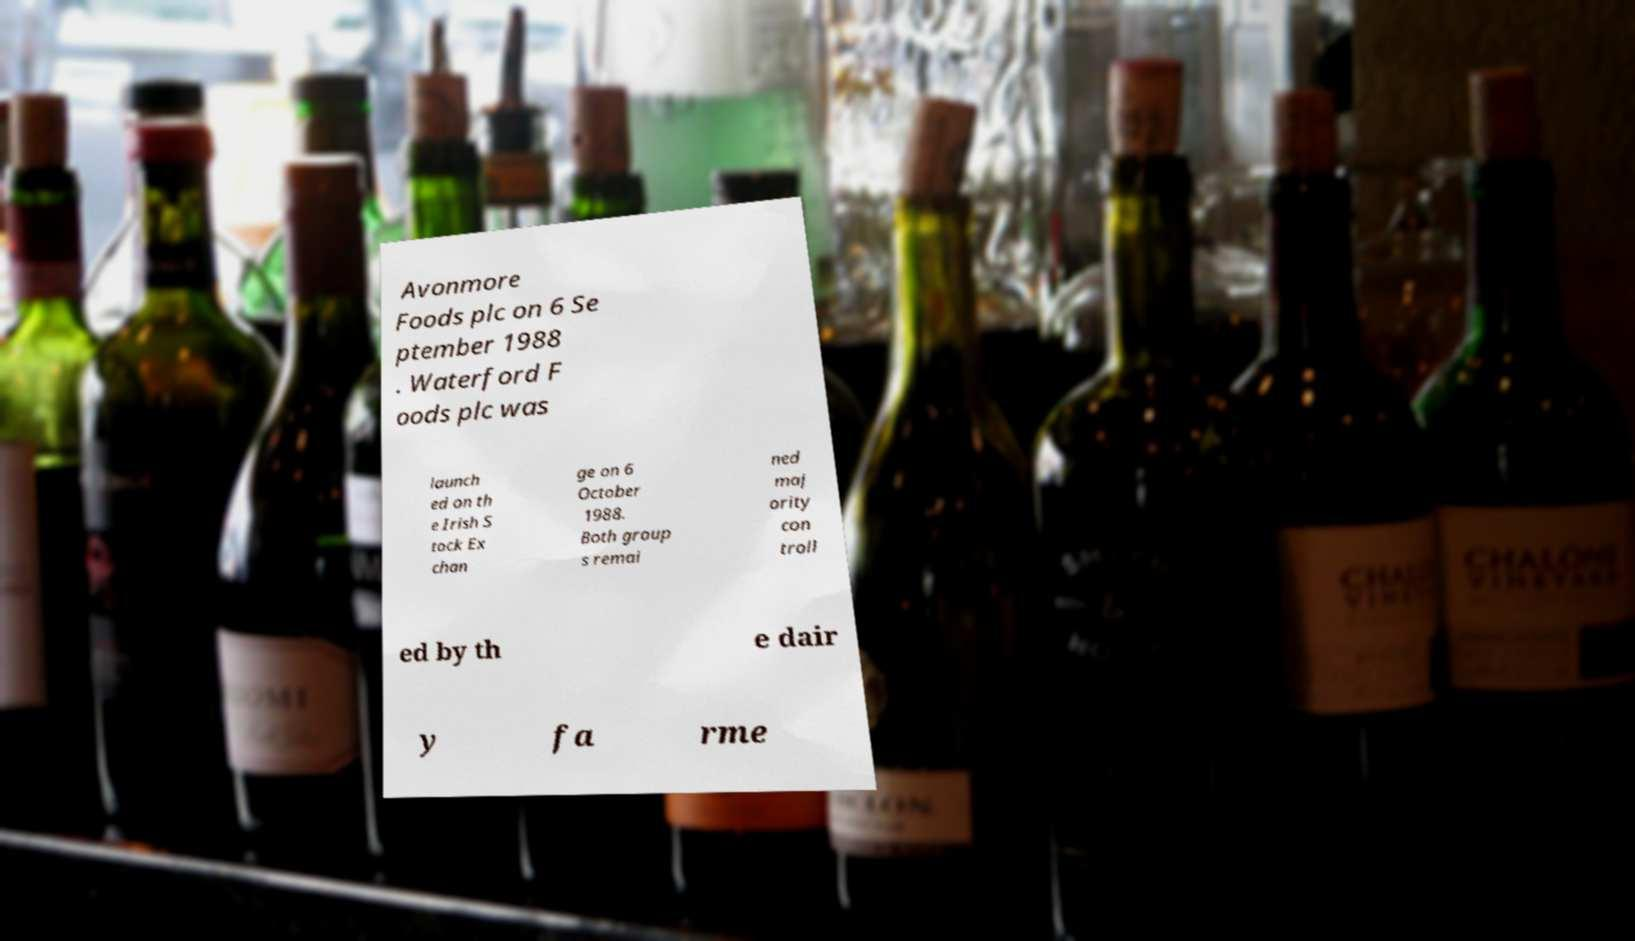I need the written content from this picture converted into text. Can you do that? Avonmore Foods plc on 6 Se ptember 1988 . Waterford F oods plc was launch ed on th e Irish S tock Ex chan ge on 6 October 1988. Both group s remai ned maj ority con troll ed by th e dair y fa rme 